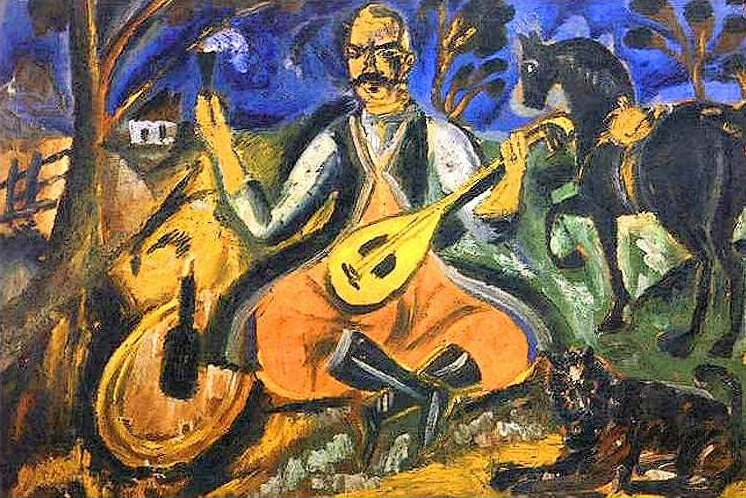What are the key elements in this picture?
 The image is a vibrant oil painting rendered in a post-impressionist style. It captures a tranquil rural setting where a man is engrossed in playing a lute. He is comfortably seated on a rock, dressed in a white shirt and orange pants, suggesting a casual, relaxed atmosphere. A loyal black dog sits attentively at his feet, adding a sense of companionship to the scene.

The background unfolds a serene landscape dotted with trees, a house, and a cow, further emphasizing the rural theme. The artist has employed a bold palette dominated by shades of blue, orange, and green, which brings the scene to life with a sense of warmth and vibrancy. The use of bold colors and brushstrokes is characteristic of the post-impressionist style, adding texture and depth to the painting.

Overall, the painting beautifully encapsulates a moment of leisure and harmony in a rural setting, brought to life through the artist's skillful use of color and form. The post-impressionist style adds a unique charm, making the painting a captivating piece of art. 